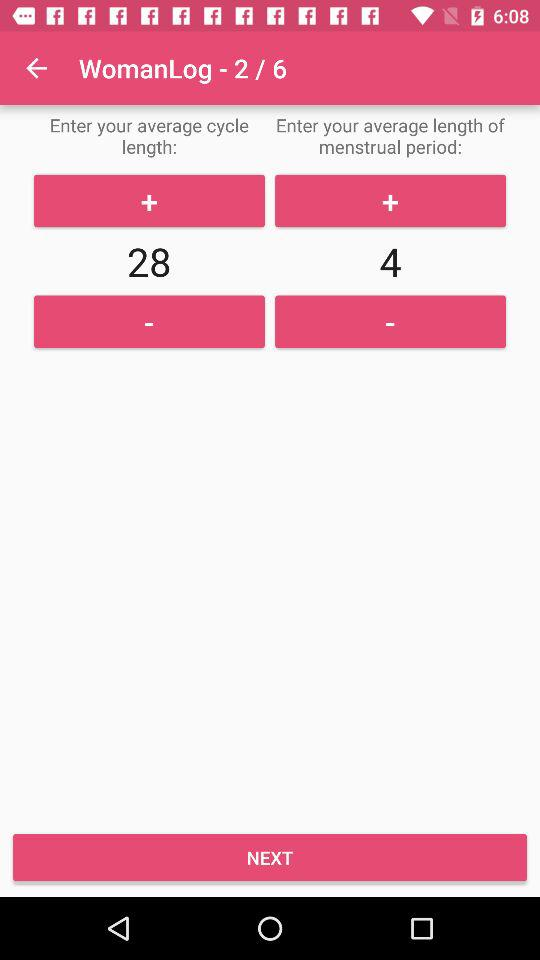What is the average length of a menstrual period? The average length of a menstrual period is 4. 